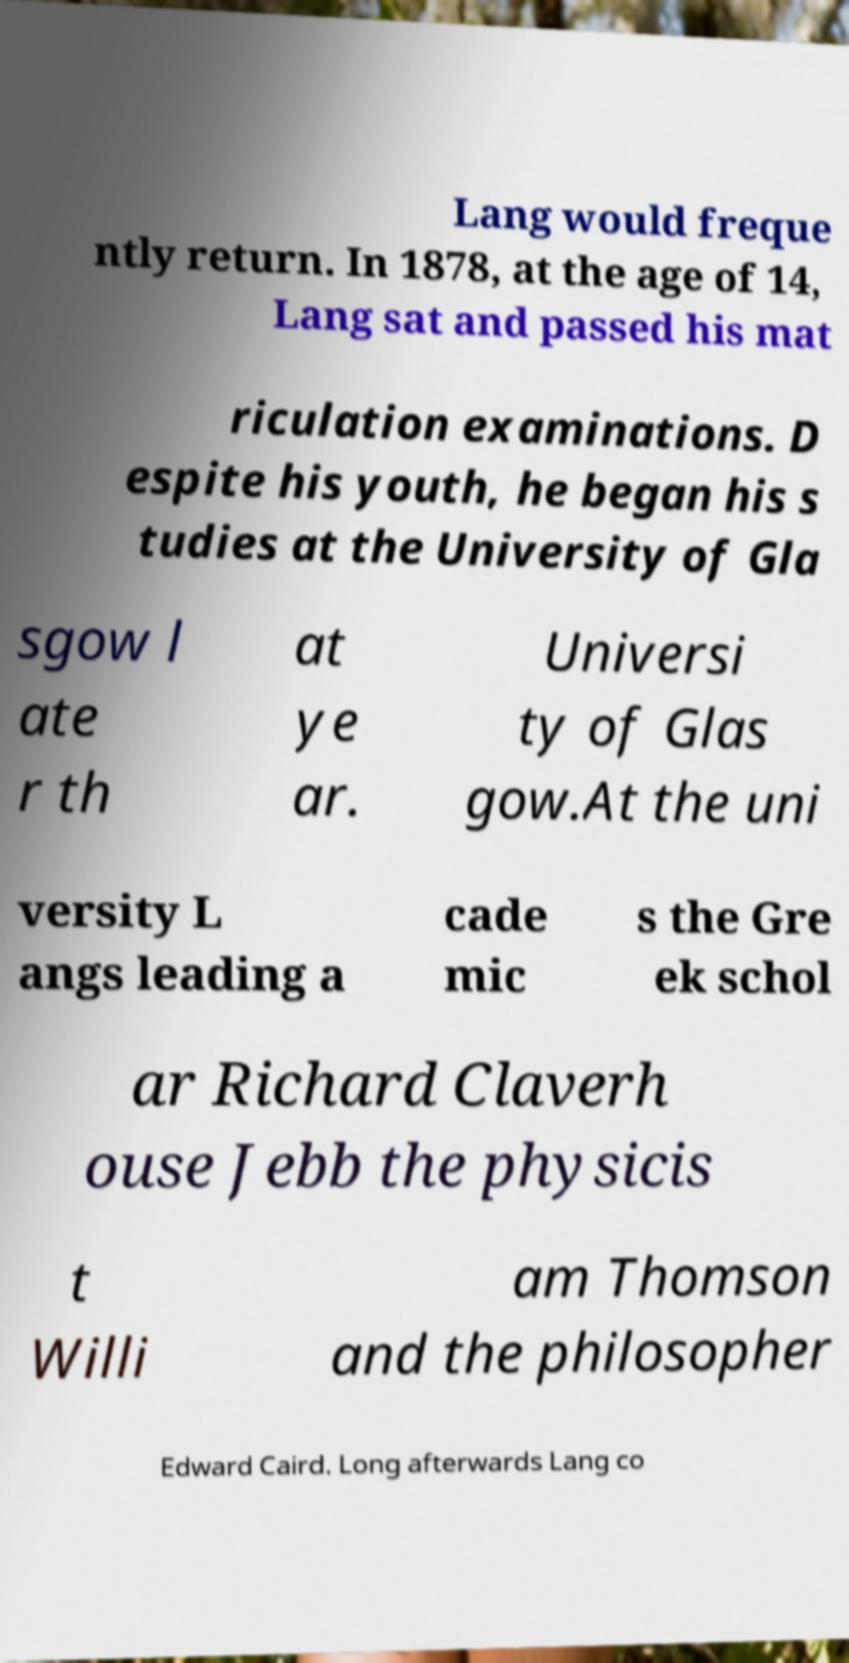Can you read and provide the text displayed in the image?This photo seems to have some interesting text. Can you extract and type it out for me? Lang would freque ntly return. In 1878, at the age of 14, Lang sat and passed his mat riculation examinations. D espite his youth, he began his s tudies at the University of Gla sgow l ate r th at ye ar. Universi ty of Glas gow.At the uni versity L angs leading a cade mic s the Gre ek schol ar Richard Claverh ouse Jebb the physicis t Willi am Thomson and the philosopher Edward Caird. Long afterwards Lang co 